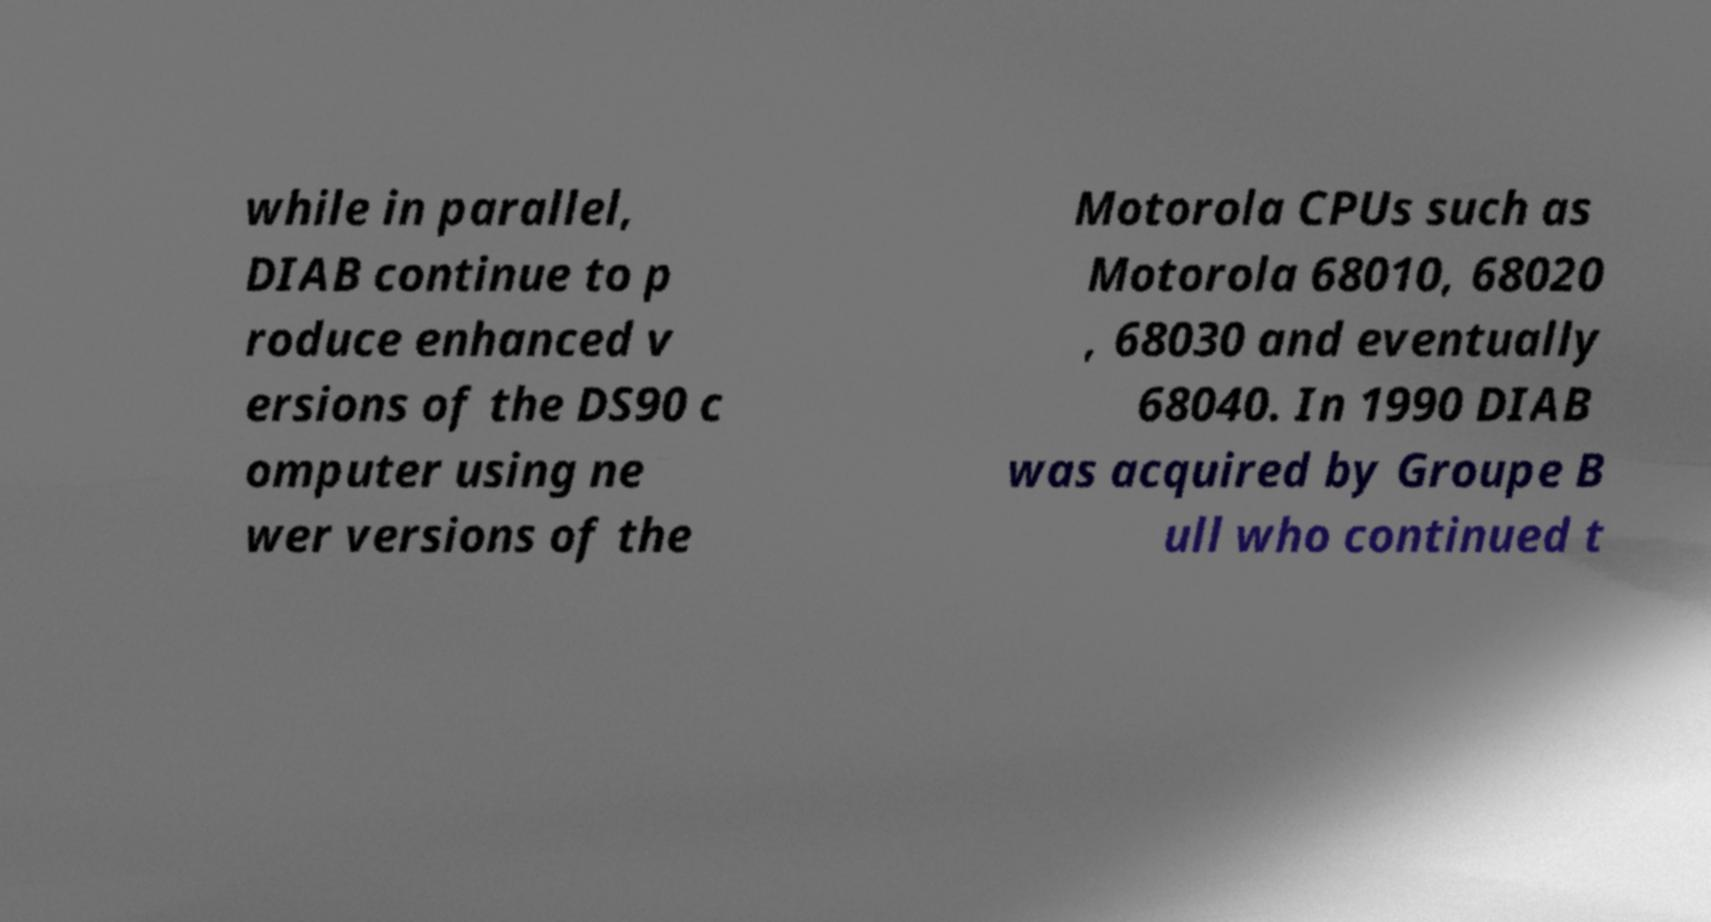Please identify and transcribe the text found in this image. while in parallel, DIAB continue to p roduce enhanced v ersions of the DS90 c omputer using ne wer versions of the Motorola CPUs such as Motorola 68010, 68020 , 68030 and eventually 68040. In 1990 DIAB was acquired by Groupe B ull who continued t 